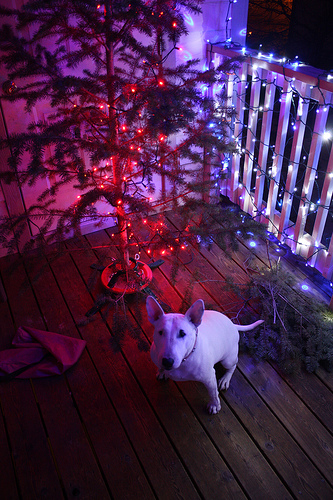<image>
Is there a tree on the balcony? Yes. Looking at the image, I can see the tree is positioned on top of the balcony, with the balcony providing support. Where is the dog in relation to the deck? Is it on the deck? Yes. Looking at the image, I can see the dog is positioned on top of the deck, with the deck providing support. 